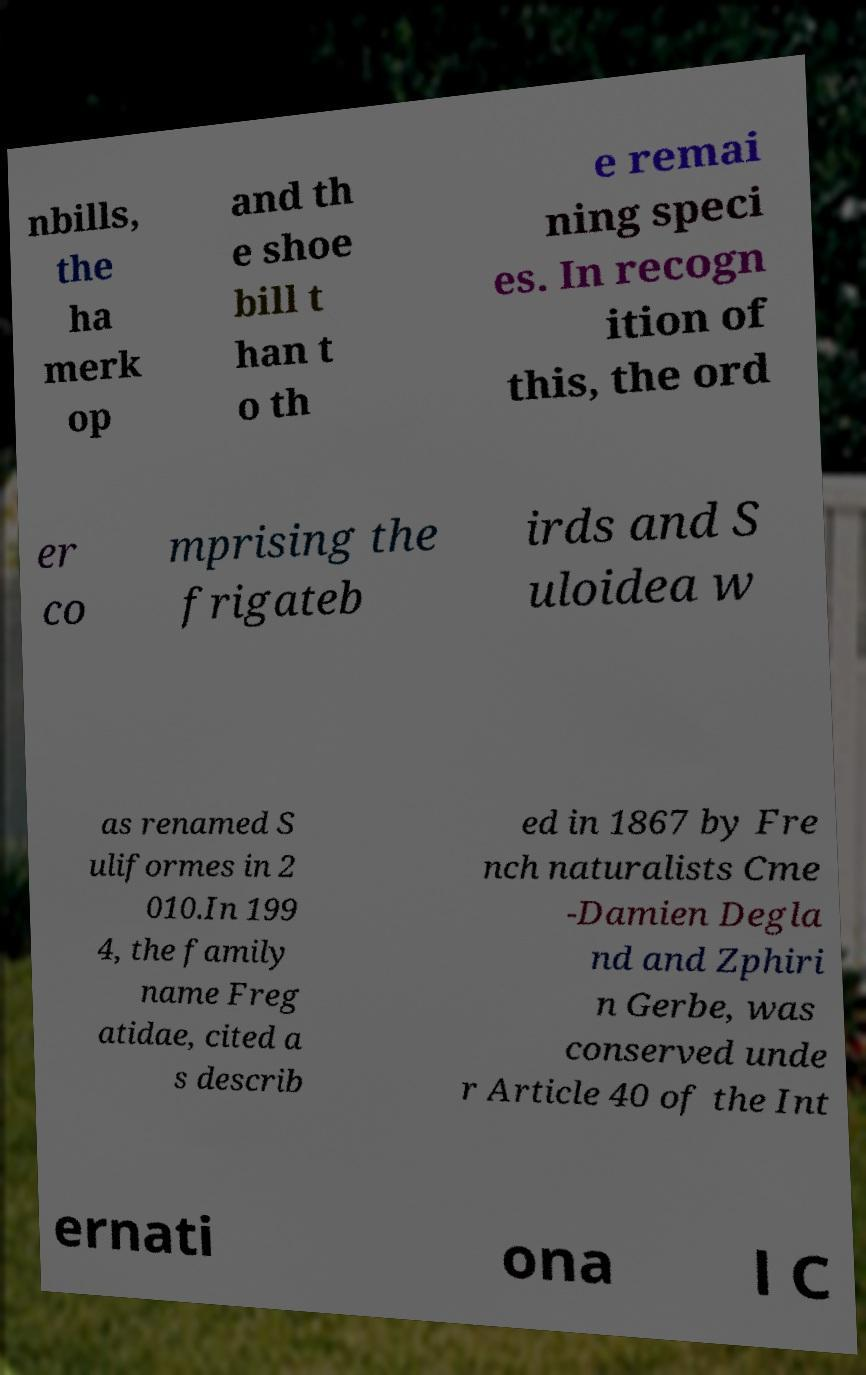Could you assist in decoding the text presented in this image and type it out clearly? nbills, the ha merk op and th e shoe bill t han t o th e remai ning speci es. In recogn ition of this, the ord er co mprising the frigateb irds and S uloidea w as renamed S uliformes in 2 010.In 199 4, the family name Freg atidae, cited a s describ ed in 1867 by Fre nch naturalists Cme -Damien Degla nd and Zphiri n Gerbe, was conserved unde r Article 40 of the Int ernati ona l C 